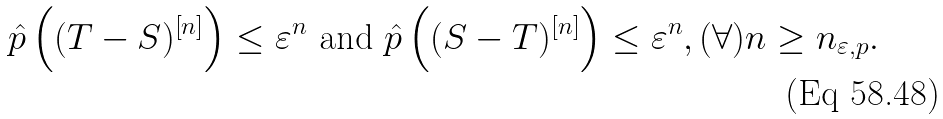Convert formula to latex. <formula><loc_0><loc_0><loc_500><loc_500>\hat { p } \left ( ( T - S ) ^ { \left [ n \right ] } \right ) \leq \varepsilon ^ { n } \text { and } \hat { p } \left ( ( S - T ) ^ { \left [ n \right ] } \right ) \leq \varepsilon ^ { n } , ( \forall ) n \geq n _ { \varepsilon , p } .</formula> 